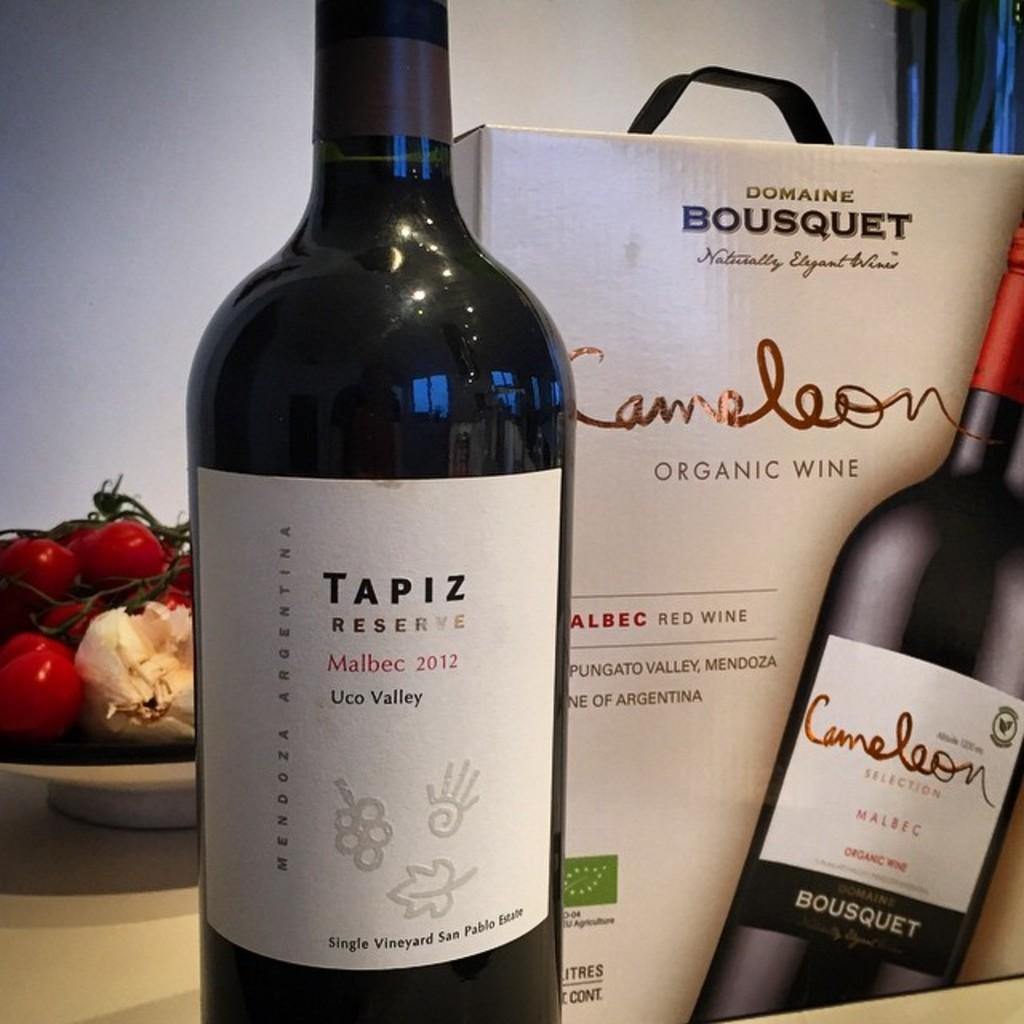<image>
Provide a brief description of the given image. A black Tapiz Reserve wine bottle and its accompanying box. 